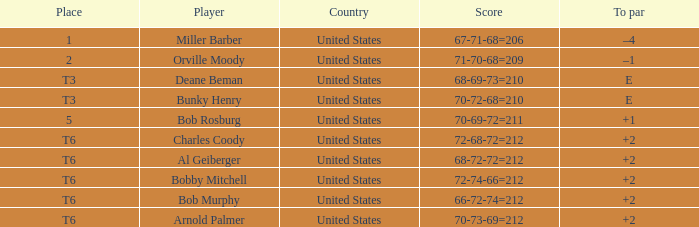Who is the athlete with a t6 position and a 72-68-72=212 score? Charles Coody. 